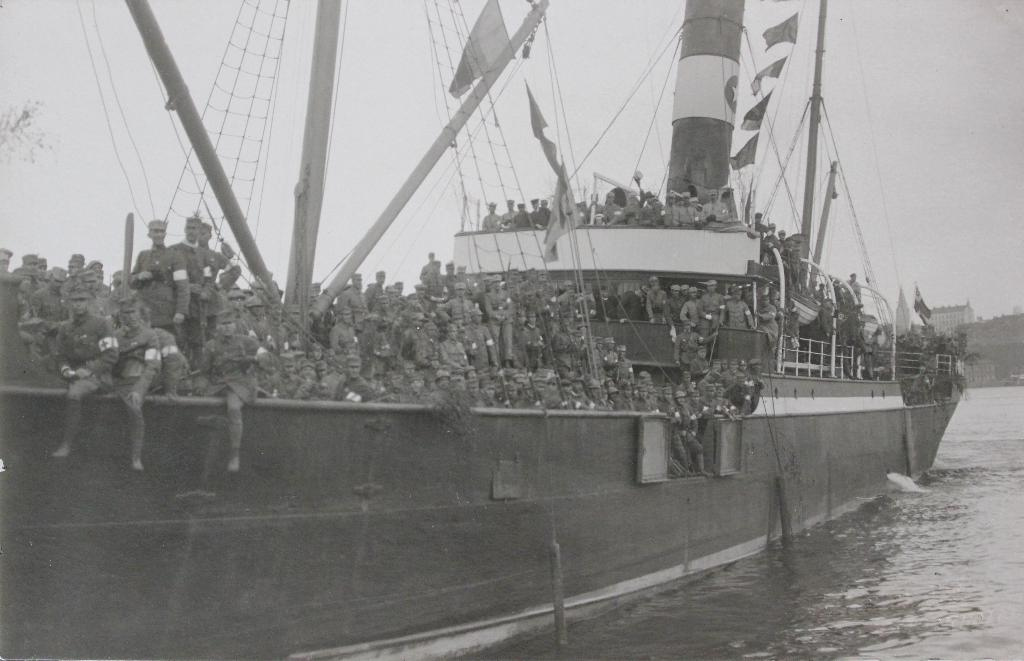What is the main subject of the image? The main subject of the image is a ship. Where is the ship located in the image? The ship is on the water. Can you describe the people on the ship? There is a group of people on the ship. What features can be seen on the ship? The ship has poles, flags, a fence, and nets. What is visible in the background of the image? There is a building and the sky in the background of the image. What type of animals can be seen in the zoo in the image? There is no zoo present in the image; it features a ship on the water. How does the fog affect visibility in the image? There is no fog present in the image; the sky is visible in the background. 